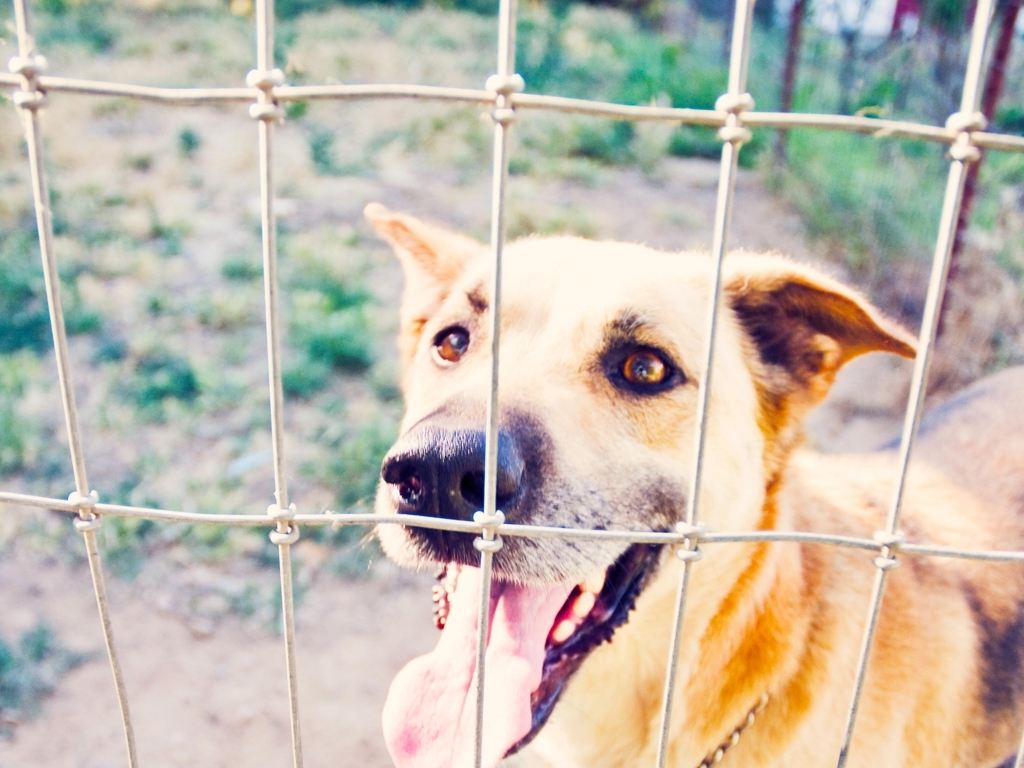What emotions does the dog's expression convey? The dog's expression seems to blend curiosity with a kind of hopeful anticipation. Its eyes and slightly open mouth might suggest it's waiting for something or someone, adding a poignant sense to the image. 